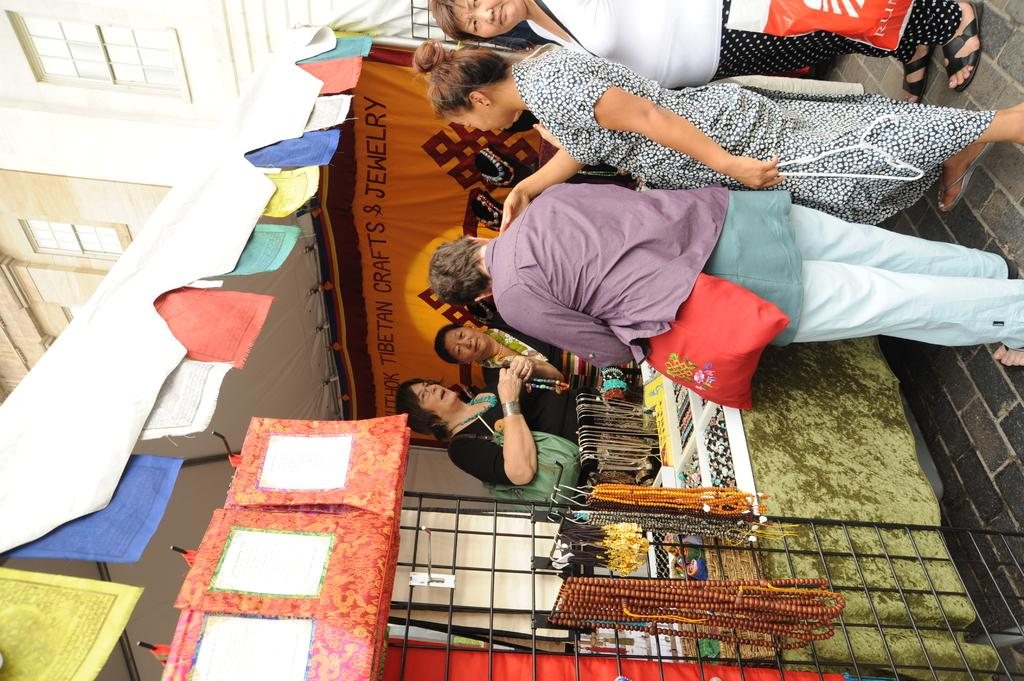What is the main subject in the middle of the image? There is a store-like structure in the middle of the image. Are there any people near the store? Yes, there are people standing near the store. What can be seen on the left side of the image? There is a building on the left side of the image. What flavor of bread is being sold in the store? There is no information about the type of bread being sold in the store, nor is there any indication of bread being sold in the image. 